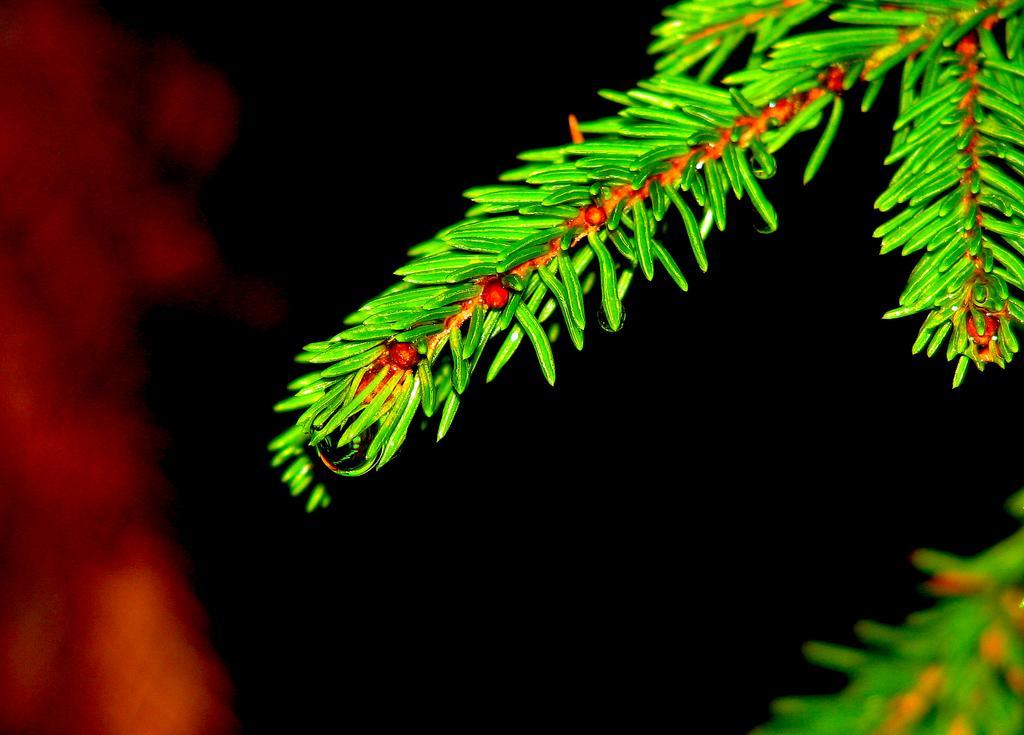Could you give a brief overview of what you see in this image? In this image there is a branch of a Christmas tree as we can see on the top of this image. 